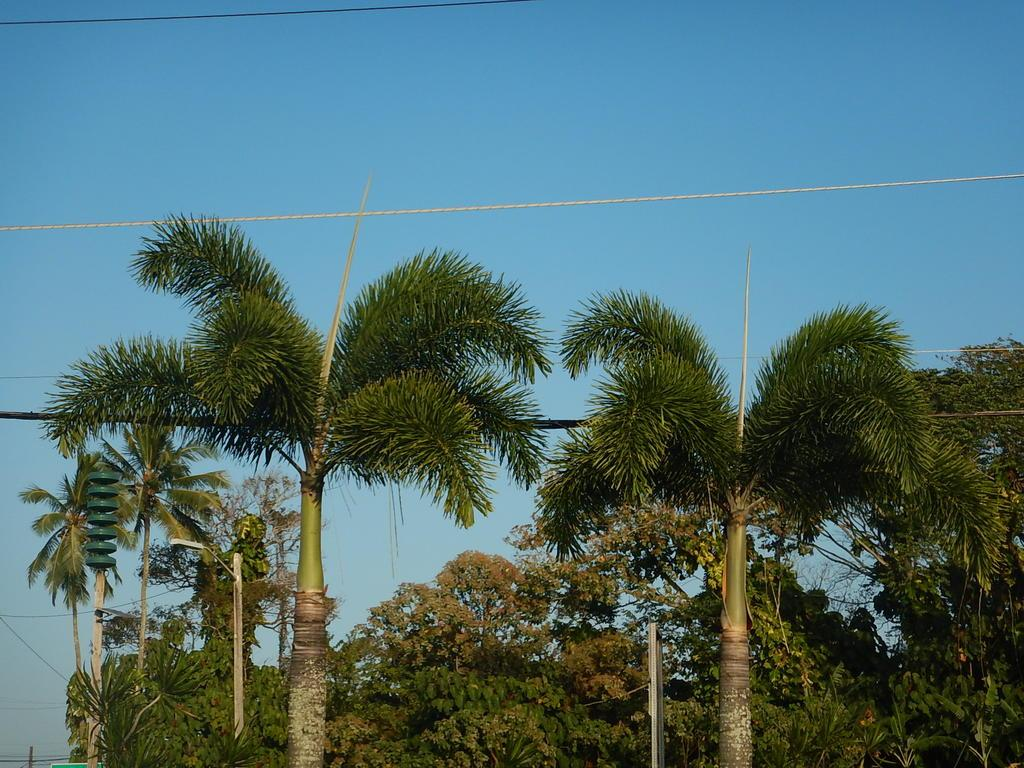What type of vegetation can be seen in the image? There are tall trees in the image. What can be seen in the background of the image? The background of the image includes a blue sky. What type of manager is depicted in the image? There is no manager present in the image; it features tall trees and a blue sky. What kind of horn can be seen in the image? There is no horn present in the image; it only includes tall trees and a blue sky. 